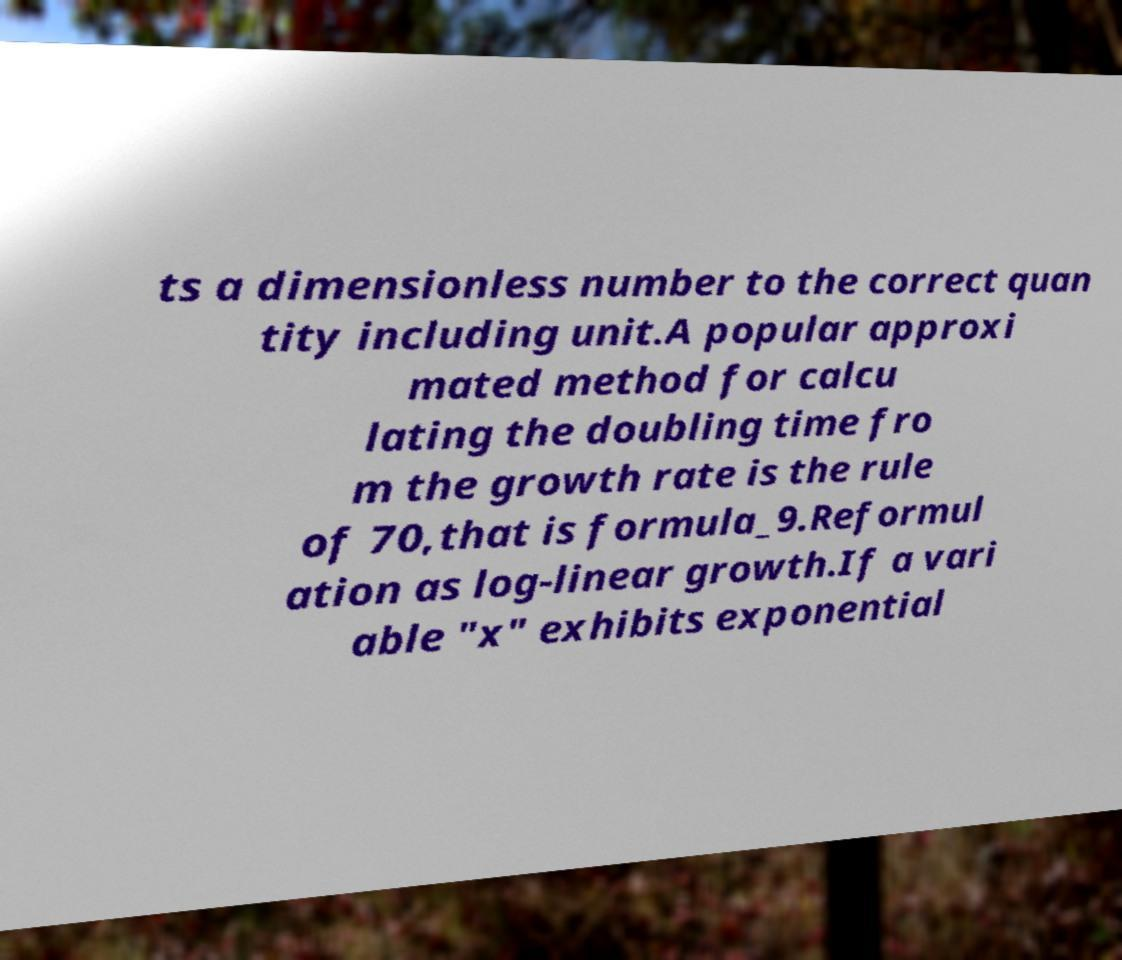Could you assist in decoding the text presented in this image and type it out clearly? ts a dimensionless number to the correct quan tity including unit.A popular approxi mated method for calcu lating the doubling time fro m the growth rate is the rule of 70,that is formula_9.Reformul ation as log-linear growth.If a vari able "x" exhibits exponential 